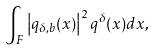<formula> <loc_0><loc_0><loc_500><loc_500>\int _ { F } \left | q _ { \delta , b } ( x ) \right | ^ { 2 } q ^ { \delta } ( x ) d x ,</formula> 